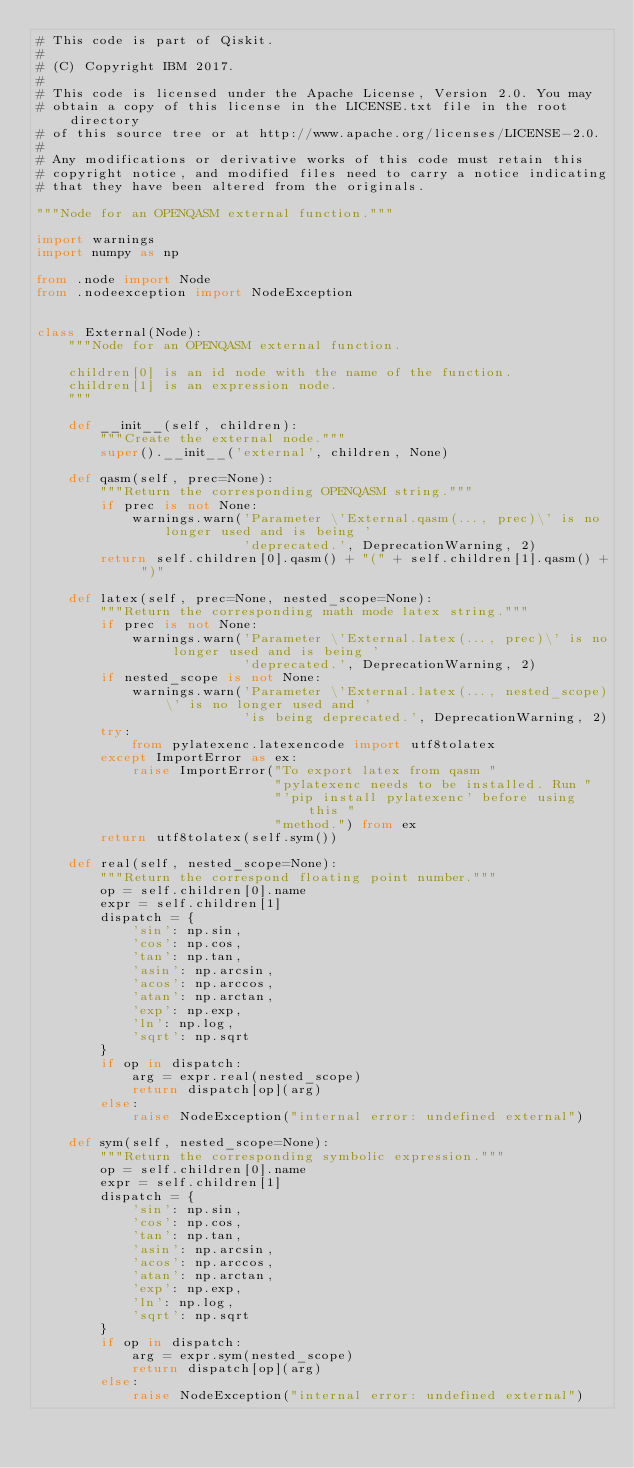Convert code to text. <code><loc_0><loc_0><loc_500><loc_500><_Python_># This code is part of Qiskit.
#
# (C) Copyright IBM 2017.
#
# This code is licensed under the Apache License, Version 2.0. You may
# obtain a copy of this license in the LICENSE.txt file in the root directory
# of this source tree or at http://www.apache.org/licenses/LICENSE-2.0.
#
# Any modifications or derivative works of this code must retain this
# copyright notice, and modified files need to carry a notice indicating
# that they have been altered from the originals.

"""Node for an OPENQASM external function."""

import warnings
import numpy as np

from .node import Node
from .nodeexception import NodeException


class External(Node):
    """Node for an OPENQASM external function.

    children[0] is an id node with the name of the function.
    children[1] is an expression node.
    """

    def __init__(self, children):
        """Create the external node."""
        super().__init__('external', children, None)

    def qasm(self, prec=None):
        """Return the corresponding OPENQASM string."""
        if prec is not None:
            warnings.warn('Parameter \'External.qasm(..., prec)\' is no longer used and is being '
                          'deprecated.', DeprecationWarning, 2)
        return self.children[0].qasm() + "(" + self.children[1].qasm() + ")"

    def latex(self, prec=None, nested_scope=None):
        """Return the corresponding math mode latex string."""
        if prec is not None:
            warnings.warn('Parameter \'External.latex(..., prec)\' is no longer used and is being '
                          'deprecated.', DeprecationWarning, 2)
        if nested_scope is not None:
            warnings.warn('Parameter \'External.latex(..., nested_scope)\' is no longer used and '
                          'is being deprecated.', DeprecationWarning, 2)
        try:
            from pylatexenc.latexencode import utf8tolatex
        except ImportError as ex:
            raise ImportError("To export latex from qasm "
                              "pylatexenc needs to be installed. Run "
                              "'pip install pylatexenc' before using this "
                              "method.") from ex
        return utf8tolatex(self.sym())

    def real(self, nested_scope=None):
        """Return the correspond floating point number."""
        op = self.children[0].name
        expr = self.children[1]
        dispatch = {
            'sin': np.sin,
            'cos': np.cos,
            'tan': np.tan,
            'asin': np.arcsin,
            'acos': np.arccos,
            'atan': np.arctan,
            'exp': np.exp,
            'ln': np.log,
            'sqrt': np.sqrt
        }
        if op in dispatch:
            arg = expr.real(nested_scope)
            return dispatch[op](arg)
        else:
            raise NodeException("internal error: undefined external")

    def sym(self, nested_scope=None):
        """Return the corresponding symbolic expression."""
        op = self.children[0].name
        expr = self.children[1]
        dispatch = {
            'sin': np.sin,
            'cos': np.cos,
            'tan': np.tan,
            'asin': np.arcsin,
            'acos': np.arccos,
            'atan': np.arctan,
            'exp': np.exp,
            'ln': np.log,
            'sqrt': np.sqrt
        }
        if op in dispatch:
            arg = expr.sym(nested_scope)
            return dispatch[op](arg)
        else:
            raise NodeException("internal error: undefined external")
</code> 